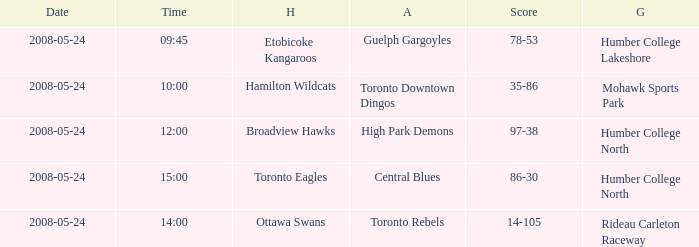Would you mind parsing the complete table? {'header': ['Date', 'Time', 'H', 'A', 'Score', 'G'], 'rows': [['2008-05-24', '09:45', 'Etobicoke Kangaroos', 'Guelph Gargoyles', '78-53', 'Humber College Lakeshore'], ['2008-05-24', '10:00', 'Hamilton Wildcats', 'Toronto Downtown Dingos', '35-86', 'Mohawk Sports Park'], ['2008-05-24', '12:00', 'Broadview Hawks', 'High Park Demons', '97-38', 'Humber College North'], ['2008-05-24', '15:00', 'Toronto Eagles', 'Central Blues', '86-30', 'Humber College North'], ['2008-05-24', '14:00', 'Ottawa Swans', 'Toronto Rebels', '14-105', 'Rideau Carleton Raceway']]} On what day was the game that ended in a score of 97-38? 2008-05-24. 